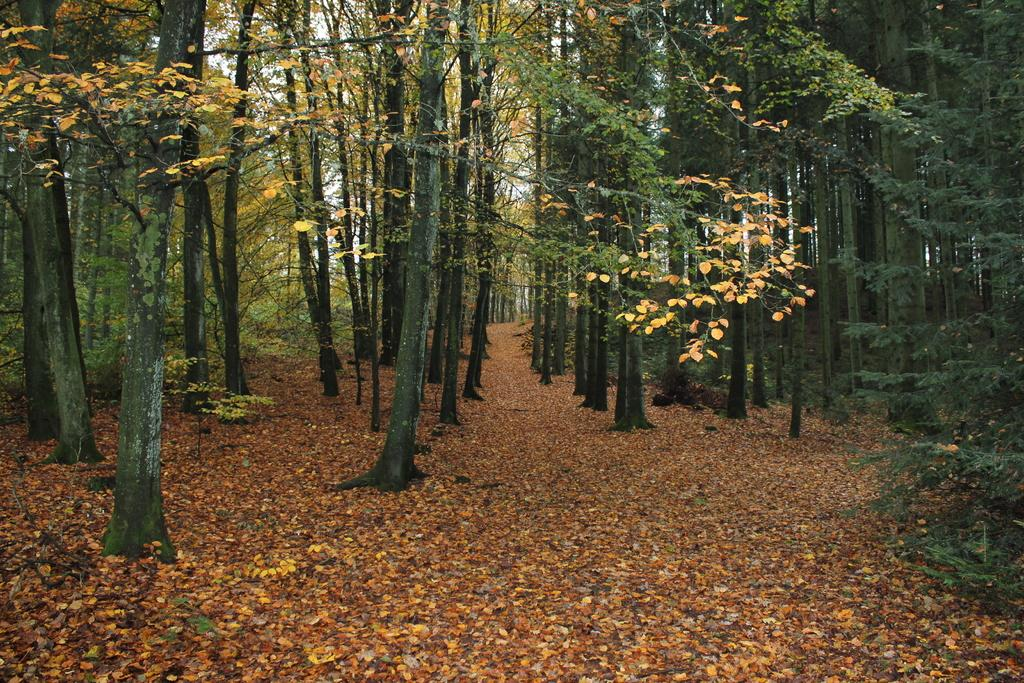What type of vegetation can be seen in the image? There are trees in the image. What can be found on the ground beneath the trees? Leaves are present on the ground in the image. What grade is the trousers being worn by the coil in the image? There is no coil or trousers present in the image; it only features trees and leaves on the ground. 